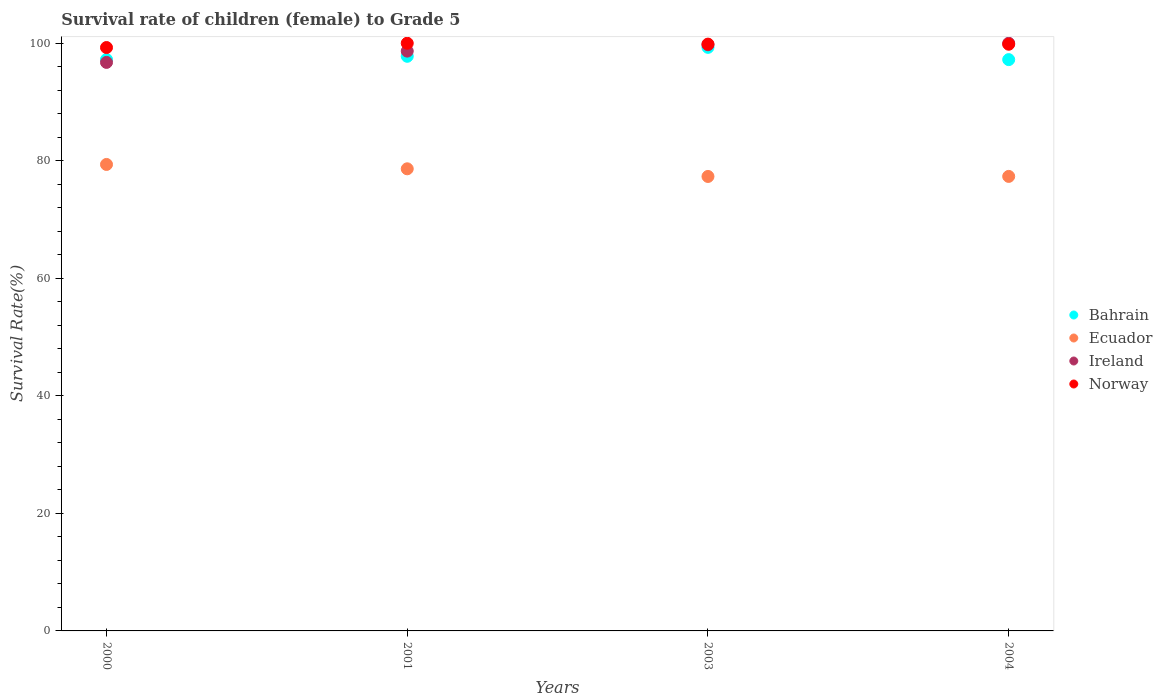How many different coloured dotlines are there?
Your response must be concise. 4. Is the number of dotlines equal to the number of legend labels?
Ensure brevity in your answer.  Yes. What is the survival rate of female children to grade 5 in Ireland in 2000?
Ensure brevity in your answer.  96.74. Across all years, what is the maximum survival rate of female children to grade 5 in Ecuador?
Your answer should be very brief. 79.37. Across all years, what is the minimum survival rate of female children to grade 5 in Ecuador?
Make the answer very short. 77.33. In which year was the survival rate of female children to grade 5 in Bahrain maximum?
Offer a terse response. 2003. In which year was the survival rate of female children to grade 5 in Norway minimum?
Offer a very short reply. 2000. What is the total survival rate of female children to grade 5 in Bahrain in the graph?
Your answer should be compact. 391.52. What is the difference between the survival rate of female children to grade 5 in Ecuador in 2003 and that in 2004?
Your answer should be compact. -0.01. What is the difference between the survival rate of female children to grade 5 in Bahrain in 2004 and the survival rate of female children to grade 5 in Norway in 2001?
Make the answer very short. -2.79. What is the average survival rate of female children to grade 5 in Bahrain per year?
Offer a terse response. 97.88. In the year 2000, what is the difference between the survival rate of female children to grade 5 in Ireland and survival rate of female children to grade 5 in Bahrain?
Ensure brevity in your answer.  -0.49. In how many years, is the survival rate of female children to grade 5 in Bahrain greater than 12 %?
Your response must be concise. 4. What is the ratio of the survival rate of female children to grade 5 in Bahrain in 2000 to that in 2001?
Your answer should be very brief. 0.99. Is the difference between the survival rate of female children to grade 5 in Ireland in 2000 and 2003 greater than the difference between the survival rate of female children to grade 5 in Bahrain in 2000 and 2003?
Your response must be concise. No. What is the difference between the highest and the second highest survival rate of female children to grade 5 in Ecuador?
Ensure brevity in your answer.  0.74. What is the difference between the highest and the lowest survival rate of female children to grade 5 in Ecuador?
Keep it short and to the point. 2.04. In how many years, is the survival rate of female children to grade 5 in Ecuador greater than the average survival rate of female children to grade 5 in Ecuador taken over all years?
Give a very brief answer. 2. Does the survival rate of female children to grade 5 in Ecuador monotonically increase over the years?
Offer a very short reply. No. Is the survival rate of female children to grade 5 in Bahrain strictly greater than the survival rate of female children to grade 5 in Ireland over the years?
Make the answer very short. No. Is the survival rate of female children to grade 5 in Ecuador strictly less than the survival rate of female children to grade 5 in Ireland over the years?
Provide a succinct answer. Yes. How many dotlines are there?
Provide a short and direct response. 4. What is the difference between two consecutive major ticks on the Y-axis?
Your answer should be very brief. 20. Does the graph contain grids?
Give a very brief answer. No. How many legend labels are there?
Give a very brief answer. 4. What is the title of the graph?
Keep it short and to the point. Survival rate of children (female) to Grade 5. What is the label or title of the X-axis?
Your answer should be compact. Years. What is the label or title of the Y-axis?
Offer a terse response. Survival Rate(%). What is the Survival Rate(%) of Bahrain in 2000?
Your answer should be very brief. 97.23. What is the Survival Rate(%) of Ecuador in 2000?
Provide a short and direct response. 79.37. What is the Survival Rate(%) in Ireland in 2000?
Provide a succinct answer. 96.74. What is the Survival Rate(%) of Norway in 2000?
Keep it short and to the point. 99.27. What is the Survival Rate(%) of Bahrain in 2001?
Make the answer very short. 97.78. What is the Survival Rate(%) in Ecuador in 2001?
Give a very brief answer. 78.63. What is the Survival Rate(%) in Ireland in 2001?
Offer a very short reply. 98.66. What is the Survival Rate(%) of Bahrain in 2003?
Provide a succinct answer. 99.3. What is the Survival Rate(%) in Ecuador in 2003?
Provide a short and direct response. 77.33. What is the Survival Rate(%) in Ireland in 2003?
Your answer should be very brief. 99.74. What is the Survival Rate(%) of Norway in 2003?
Your response must be concise. 99.85. What is the Survival Rate(%) of Bahrain in 2004?
Provide a succinct answer. 97.21. What is the Survival Rate(%) of Ecuador in 2004?
Give a very brief answer. 77.34. What is the Survival Rate(%) of Ireland in 2004?
Offer a very short reply. 100. What is the Survival Rate(%) of Norway in 2004?
Provide a short and direct response. 99.83. Across all years, what is the maximum Survival Rate(%) of Bahrain?
Your answer should be compact. 99.3. Across all years, what is the maximum Survival Rate(%) of Ecuador?
Ensure brevity in your answer.  79.37. Across all years, what is the maximum Survival Rate(%) of Ireland?
Offer a very short reply. 100. Across all years, what is the minimum Survival Rate(%) in Bahrain?
Make the answer very short. 97.21. Across all years, what is the minimum Survival Rate(%) in Ecuador?
Keep it short and to the point. 77.33. Across all years, what is the minimum Survival Rate(%) of Ireland?
Provide a succinct answer. 96.74. Across all years, what is the minimum Survival Rate(%) in Norway?
Provide a succinct answer. 99.27. What is the total Survival Rate(%) of Bahrain in the graph?
Your answer should be very brief. 391.52. What is the total Survival Rate(%) of Ecuador in the graph?
Give a very brief answer. 312.68. What is the total Survival Rate(%) of Ireland in the graph?
Give a very brief answer. 395.14. What is the total Survival Rate(%) of Norway in the graph?
Ensure brevity in your answer.  398.95. What is the difference between the Survival Rate(%) of Bahrain in 2000 and that in 2001?
Make the answer very short. -0.55. What is the difference between the Survival Rate(%) in Ecuador in 2000 and that in 2001?
Make the answer very short. 0.74. What is the difference between the Survival Rate(%) in Ireland in 2000 and that in 2001?
Give a very brief answer. -1.92. What is the difference between the Survival Rate(%) of Norway in 2000 and that in 2001?
Give a very brief answer. -0.73. What is the difference between the Survival Rate(%) in Bahrain in 2000 and that in 2003?
Provide a succinct answer. -2.07. What is the difference between the Survival Rate(%) in Ecuador in 2000 and that in 2003?
Provide a short and direct response. 2.04. What is the difference between the Survival Rate(%) in Ireland in 2000 and that in 2003?
Make the answer very short. -3. What is the difference between the Survival Rate(%) in Norway in 2000 and that in 2003?
Ensure brevity in your answer.  -0.58. What is the difference between the Survival Rate(%) in Bahrain in 2000 and that in 2004?
Your answer should be compact. 0.01. What is the difference between the Survival Rate(%) in Ecuador in 2000 and that in 2004?
Offer a terse response. 2.03. What is the difference between the Survival Rate(%) in Ireland in 2000 and that in 2004?
Provide a short and direct response. -3.26. What is the difference between the Survival Rate(%) in Norway in 2000 and that in 2004?
Make the answer very short. -0.56. What is the difference between the Survival Rate(%) in Bahrain in 2001 and that in 2003?
Your response must be concise. -1.52. What is the difference between the Survival Rate(%) in Ecuador in 2001 and that in 2003?
Your response must be concise. 1.3. What is the difference between the Survival Rate(%) of Ireland in 2001 and that in 2003?
Provide a short and direct response. -1.08. What is the difference between the Survival Rate(%) in Norway in 2001 and that in 2003?
Offer a terse response. 0.15. What is the difference between the Survival Rate(%) in Bahrain in 2001 and that in 2004?
Your answer should be compact. 0.57. What is the difference between the Survival Rate(%) in Ecuador in 2001 and that in 2004?
Provide a succinct answer. 1.29. What is the difference between the Survival Rate(%) of Ireland in 2001 and that in 2004?
Make the answer very short. -1.34. What is the difference between the Survival Rate(%) of Norway in 2001 and that in 2004?
Provide a succinct answer. 0.17. What is the difference between the Survival Rate(%) of Bahrain in 2003 and that in 2004?
Give a very brief answer. 2.09. What is the difference between the Survival Rate(%) in Ecuador in 2003 and that in 2004?
Ensure brevity in your answer.  -0.01. What is the difference between the Survival Rate(%) of Ireland in 2003 and that in 2004?
Make the answer very short. -0.26. What is the difference between the Survival Rate(%) in Norway in 2003 and that in 2004?
Your answer should be very brief. 0.02. What is the difference between the Survival Rate(%) in Bahrain in 2000 and the Survival Rate(%) in Ecuador in 2001?
Provide a succinct answer. 18.59. What is the difference between the Survival Rate(%) of Bahrain in 2000 and the Survival Rate(%) of Ireland in 2001?
Your answer should be compact. -1.43. What is the difference between the Survival Rate(%) in Bahrain in 2000 and the Survival Rate(%) in Norway in 2001?
Your answer should be compact. -2.77. What is the difference between the Survival Rate(%) in Ecuador in 2000 and the Survival Rate(%) in Ireland in 2001?
Offer a very short reply. -19.29. What is the difference between the Survival Rate(%) of Ecuador in 2000 and the Survival Rate(%) of Norway in 2001?
Your response must be concise. -20.63. What is the difference between the Survival Rate(%) of Ireland in 2000 and the Survival Rate(%) of Norway in 2001?
Your response must be concise. -3.26. What is the difference between the Survival Rate(%) in Bahrain in 2000 and the Survival Rate(%) in Ecuador in 2003?
Keep it short and to the point. 19.9. What is the difference between the Survival Rate(%) of Bahrain in 2000 and the Survival Rate(%) of Ireland in 2003?
Your response must be concise. -2.51. What is the difference between the Survival Rate(%) in Bahrain in 2000 and the Survival Rate(%) in Norway in 2003?
Offer a terse response. -2.62. What is the difference between the Survival Rate(%) of Ecuador in 2000 and the Survival Rate(%) of Ireland in 2003?
Your answer should be very brief. -20.37. What is the difference between the Survival Rate(%) in Ecuador in 2000 and the Survival Rate(%) in Norway in 2003?
Offer a very short reply. -20.48. What is the difference between the Survival Rate(%) of Ireland in 2000 and the Survival Rate(%) of Norway in 2003?
Ensure brevity in your answer.  -3.11. What is the difference between the Survival Rate(%) of Bahrain in 2000 and the Survival Rate(%) of Ecuador in 2004?
Give a very brief answer. 19.89. What is the difference between the Survival Rate(%) in Bahrain in 2000 and the Survival Rate(%) in Ireland in 2004?
Make the answer very short. -2.77. What is the difference between the Survival Rate(%) of Bahrain in 2000 and the Survival Rate(%) of Norway in 2004?
Your response must be concise. -2.6. What is the difference between the Survival Rate(%) in Ecuador in 2000 and the Survival Rate(%) in Ireland in 2004?
Your response must be concise. -20.63. What is the difference between the Survival Rate(%) of Ecuador in 2000 and the Survival Rate(%) of Norway in 2004?
Make the answer very short. -20.46. What is the difference between the Survival Rate(%) of Ireland in 2000 and the Survival Rate(%) of Norway in 2004?
Your response must be concise. -3.09. What is the difference between the Survival Rate(%) in Bahrain in 2001 and the Survival Rate(%) in Ecuador in 2003?
Make the answer very short. 20.45. What is the difference between the Survival Rate(%) in Bahrain in 2001 and the Survival Rate(%) in Ireland in 2003?
Ensure brevity in your answer.  -1.96. What is the difference between the Survival Rate(%) in Bahrain in 2001 and the Survival Rate(%) in Norway in 2003?
Give a very brief answer. -2.07. What is the difference between the Survival Rate(%) of Ecuador in 2001 and the Survival Rate(%) of Ireland in 2003?
Give a very brief answer. -21.11. What is the difference between the Survival Rate(%) of Ecuador in 2001 and the Survival Rate(%) of Norway in 2003?
Offer a terse response. -21.22. What is the difference between the Survival Rate(%) in Ireland in 2001 and the Survival Rate(%) in Norway in 2003?
Offer a terse response. -1.19. What is the difference between the Survival Rate(%) in Bahrain in 2001 and the Survival Rate(%) in Ecuador in 2004?
Ensure brevity in your answer.  20.44. What is the difference between the Survival Rate(%) of Bahrain in 2001 and the Survival Rate(%) of Ireland in 2004?
Your answer should be compact. -2.22. What is the difference between the Survival Rate(%) in Bahrain in 2001 and the Survival Rate(%) in Norway in 2004?
Offer a very short reply. -2.05. What is the difference between the Survival Rate(%) in Ecuador in 2001 and the Survival Rate(%) in Ireland in 2004?
Keep it short and to the point. -21.37. What is the difference between the Survival Rate(%) in Ecuador in 2001 and the Survival Rate(%) in Norway in 2004?
Offer a terse response. -21.2. What is the difference between the Survival Rate(%) of Ireland in 2001 and the Survival Rate(%) of Norway in 2004?
Give a very brief answer. -1.17. What is the difference between the Survival Rate(%) in Bahrain in 2003 and the Survival Rate(%) in Ecuador in 2004?
Offer a terse response. 21.96. What is the difference between the Survival Rate(%) in Bahrain in 2003 and the Survival Rate(%) in Ireland in 2004?
Give a very brief answer. -0.7. What is the difference between the Survival Rate(%) of Bahrain in 2003 and the Survival Rate(%) of Norway in 2004?
Keep it short and to the point. -0.53. What is the difference between the Survival Rate(%) in Ecuador in 2003 and the Survival Rate(%) in Ireland in 2004?
Your answer should be compact. -22.67. What is the difference between the Survival Rate(%) of Ecuador in 2003 and the Survival Rate(%) of Norway in 2004?
Ensure brevity in your answer.  -22.5. What is the difference between the Survival Rate(%) of Ireland in 2003 and the Survival Rate(%) of Norway in 2004?
Give a very brief answer. -0.09. What is the average Survival Rate(%) in Bahrain per year?
Provide a succinct answer. 97.88. What is the average Survival Rate(%) in Ecuador per year?
Offer a very short reply. 78.17. What is the average Survival Rate(%) of Ireland per year?
Keep it short and to the point. 98.78. What is the average Survival Rate(%) of Norway per year?
Make the answer very short. 99.74. In the year 2000, what is the difference between the Survival Rate(%) of Bahrain and Survival Rate(%) of Ecuador?
Your answer should be very brief. 17.85. In the year 2000, what is the difference between the Survival Rate(%) in Bahrain and Survival Rate(%) in Ireland?
Your answer should be very brief. 0.49. In the year 2000, what is the difference between the Survival Rate(%) in Bahrain and Survival Rate(%) in Norway?
Offer a terse response. -2.04. In the year 2000, what is the difference between the Survival Rate(%) in Ecuador and Survival Rate(%) in Ireland?
Provide a short and direct response. -17.37. In the year 2000, what is the difference between the Survival Rate(%) in Ecuador and Survival Rate(%) in Norway?
Your answer should be compact. -19.9. In the year 2000, what is the difference between the Survival Rate(%) in Ireland and Survival Rate(%) in Norway?
Provide a short and direct response. -2.53. In the year 2001, what is the difference between the Survival Rate(%) of Bahrain and Survival Rate(%) of Ecuador?
Your response must be concise. 19.15. In the year 2001, what is the difference between the Survival Rate(%) of Bahrain and Survival Rate(%) of Ireland?
Your answer should be compact. -0.88. In the year 2001, what is the difference between the Survival Rate(%) in Bahrain and Survival Rate(%) in Norway?
Provide a short and direct response. -2.22. In the year 2001, what is the difference between the Survival Rate(%) of Ecuador and Survival Rate(%) of Ireland?
Provide a short and direct response. -20.03. In the year 2001, what is the difference between the Survival Rate(%) of Ecuador and Survival Rate(%) of Norway?
Your response must be concise. -21.37. In the year 2001, what is the difference between the Survival Rate(%) of Ireland and Survival Rate(%) of Norway?
Provide a short and direct response. -1.34. In the year 2003, what is the difference between the Survival Rate(%) of Bahrain and Survival Rate(%) of Ecuador?
Provide a short and direct response. 21.97. In the year 2003, what is the difference between the Survival Rate(%) in Bahrain and Survival Rate(%) in Ireland?
Offer a terse response. -0.44. In the year 2003, what is the difference between the Survival Rate(%) in Bahrain and Survival Rate(%) in Norway?
Give a very brief answer. -0.55. In the year 2003, what is the difference between the Survival Rate(%) in Ecuador and Survival Rate(%) in Ireland?
Ensure brevity in your answer.  -22.41. In the year 2003, what is the difference between the Survival Rate(%) of Ecuador and Survival Rate(%) of Norway?
Keep it short and to the point. -22.52. In the year 2003, what is the difference between the Survival Rate(%) in Ireland and Survival Rate(%) in Norway?
Provide a short and direct response. -0.11. In the year 2004, what is the difference between the Survival Rate(%) in Bahrain and Survival Rate(%) in Ecuador?
Give a very brief answer. 19.87. In the year 2004, what is the difference between the Survival Rate(%) in Bahrain and Survival Rate(%) in Ireland?
Provide a succinct answer. -2.79. In the year 2004, what is the difference between the Survival Rate(%) of Bahrain and Survival Rate(%) of Norway?
Your answer should be very brief. -2.62. In the year 2004, what is the difference between the Survival Rate(%) of Ecuador and Survival Rate(%) of Ireland?
Ensure brevity in your answer.  -22.66. In the year 2004, what is the difference between the Survival Rate(%) of Ecuador and Survival Rate(%) of Norway?
Give a very brief answer. -22.49. In the year 2004, what is the difference between the Survival Rate(%) of Ireland and Survival Rate(%) of Norway?
Make the answer very short. 0.17. What is the ratio of the Survival Rate(%) in Bahrain in 2000 to that in 2001?
Your response must be concise. 0.99. What is the ratio of the Survival Rate(%) in Ecuador in 2000 to that in 2001?
Give a very brief answer. 1.01. What is the ratio of the Survival Rate(%) in Ireland in 2000 to that in 2001?
Your response must be concise. 0.98. What is the ratio of the Survival Rate(%) of Norway in 2000 to that in 2001?
Give a very brief answer. 0.99. What is the ratio of the Survival Rate(%) of Bahrain in 2000 to that in 2003?
Provide a succinct answer. 0.98. What is the ratio of the Survival Rate(%) in Ecuador in 2000 to that in 2003?
Provide a succinct answer. 1.03. What is the ratio of the Survival Rate(%) of Ireland in 2000 to that in 2003?
Your answer should be very brief. 0.97. What is the ratio of the Survival Rate(%) in Norway in 2000 to that in 2003?
Your answer should be compact. 0.99. What is the ratio of the Survival Rate(%) in Ecuador in 2000 to that in 2004?
Offer a very short reply. 1.03. What is the ratio of the Survival Rate(%) of Ireland in 2000 to that in 2004?
Your answer should be compact. 0.97. What is the ratio of the Survival Rate(%) in Norway in 2000 to that in 2004?
Your answer should be very brief. 0.99. What is the ratio of the Survival Rate(%) in Bahrain in 2001 to that in 2003?
Offer a very short reply. 0.98. What is the ratio of the Survival Rate(%) in Ecuador in 2001 to that in 2003?
Keep it short and to the point. 1.02. What is the ratio of the Survival Rate(%) in Ecuador in 2001 to that in 2004?
Offer a very short reply. 1.02. What is the ratio of the Survival Rate(%) in Ireland in 2001 to that in 2004?
Your answer should be very brief. 0.99. What is the ratio of the Survival Rate(%) in Norway in 2001 to that in 2004?
Offer a very short reply. 1. What is the ratio of the Survival Rate(%) in Bahrain in 2003 to that in 2004?
Your answer should be compact. 1.02. What is the ratio of the Survival Rate(%) of Norway in 2003 to that in 2004?
Your answer should be very brief. 1. What is the difference between the highest and the second highest Survival Rate(%) of Bahrain?
Your response must be concise. 1.52. What is the difference between the highest and the second highest Survival Rate(%) of Ecuador?
Offer a terse response. 0.74. What is the difference between the highest and the second highest Survival Rate(%) of Ireland?
Offer a very short reply. 0.26. What is the difference between the highest and the second highest Survival Rate(%) in Norway?
Your answer should be compact. 0.15. What is the difference between the highest and the lowest Survival Rate(%) of Bahrain?
Your answer should be compact. 2.09. What is the difference between the highest and the lowest Survival Rate(%) in Ecuador?
Offer a very short reply. 2.04. What is the difference between the highest and the lowest Survival Rate(%) of Ireland?
Make the answer very short. 3.26. What is the difference between the highest and the lowest Survival Rate(%) of Norway?
Ensure brevity in your answer.  0.73. 